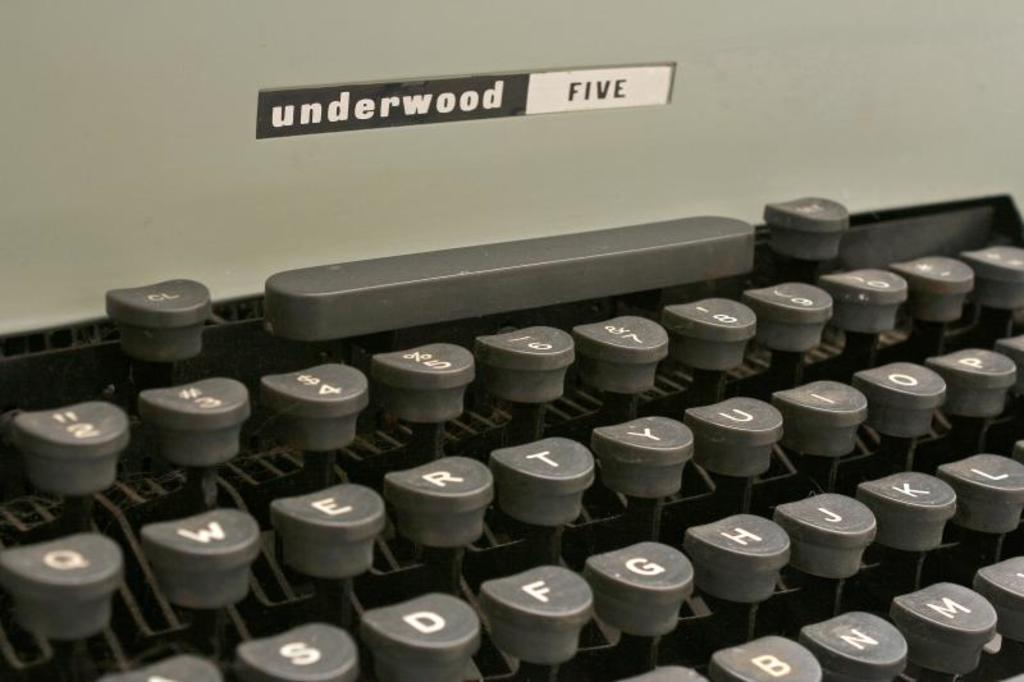<image>
Render a clear and concise summary of the photo. A old fashion brand of typewriter underwood five is pictured. 